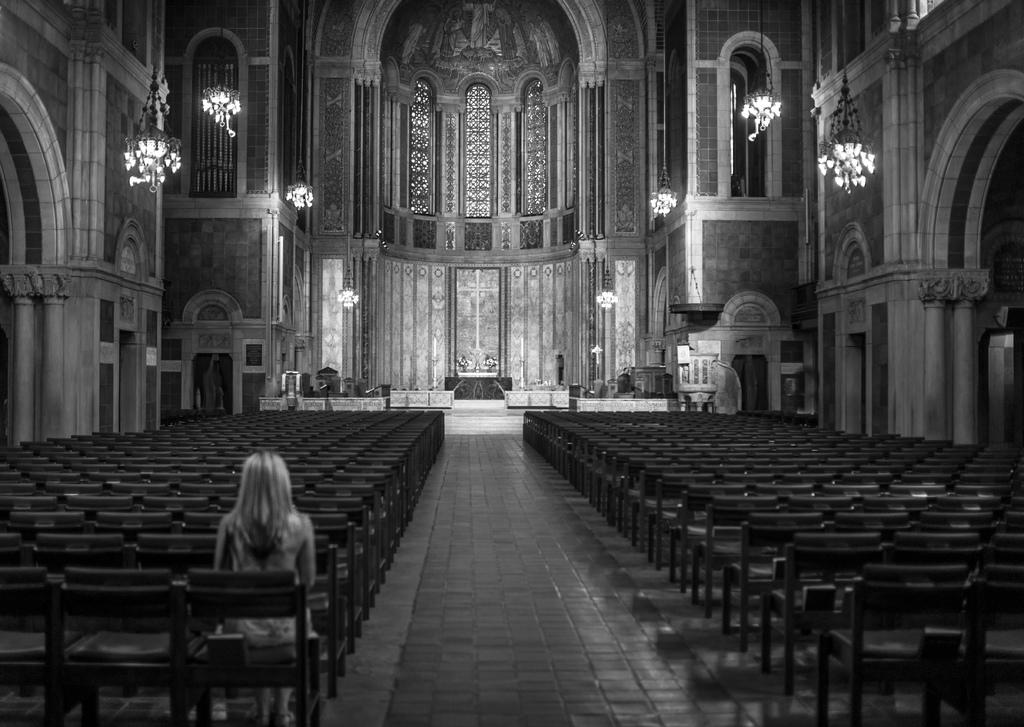What is the woman in the image doing? The woman is sitting on a chair in the image. How many chairs are visible in the image? There are empty chairs in the image. What can be seen in the background of the image? The interior of a building, lights, and a wall are visible in the background of the image. What type of lettuce is being used as a decoration on the wall in the image? There is no lettuce present in the image; it is a woman sitting on a chair with empty chairs and a background featuring the interior of a building, lights, and a wall. 